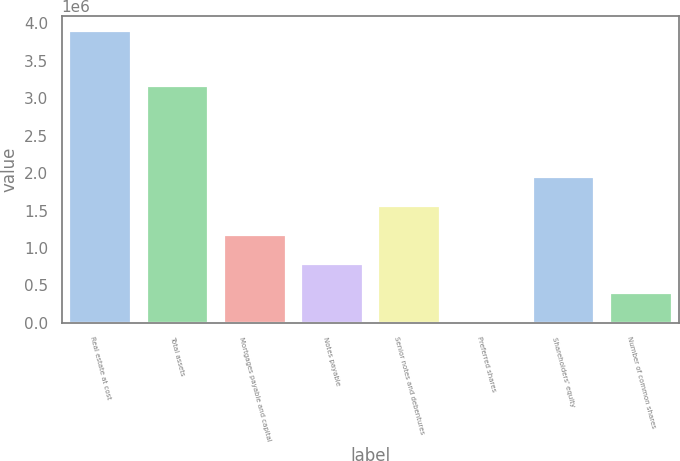<chart> <loc_0><loc_0><loc_500><loc_500><bar_chart><fcel>Real estate at cost<fcel>Total assets<fcel>Mortgages payable and capital<fcel>Notes payable<fcel>Senior notes and debentures<fcel>Preferred shares<fcel>Shareholders' equity<fcel>Number of common shares<nl><fcel>3.89594e+06<fcel>3.15955e+06<fcel>1.17578e+06<fcel>787186<fcel>1.56438e+06<fcel>9997<fcel>1.95297e+06<fcel>398592<nl></chart> 